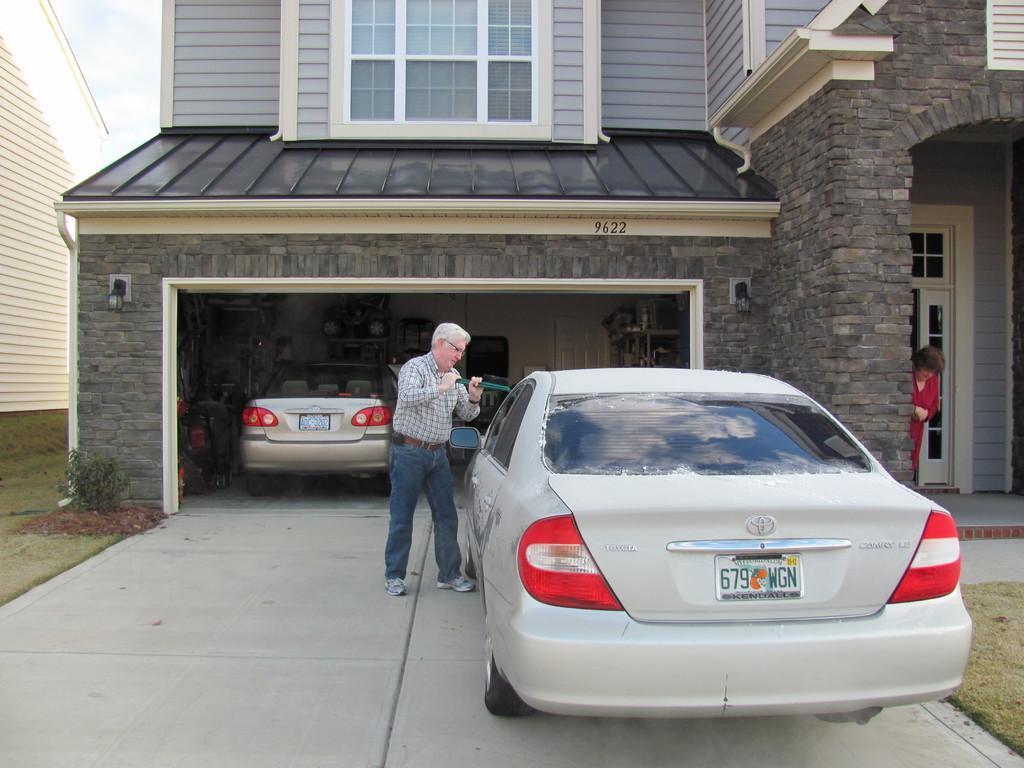In one or two sentences, can you explain what this image depicts? In this picture there is a man standing and holding the object and there is a car on the pavement and there is a car and there are objects under the shed. On the right side of the image there is a woman standing behind the wall. At the back there is a building. On the left side of the image there is a building. At the top there is sky. At the bottom there is grass and there is a pavement. 